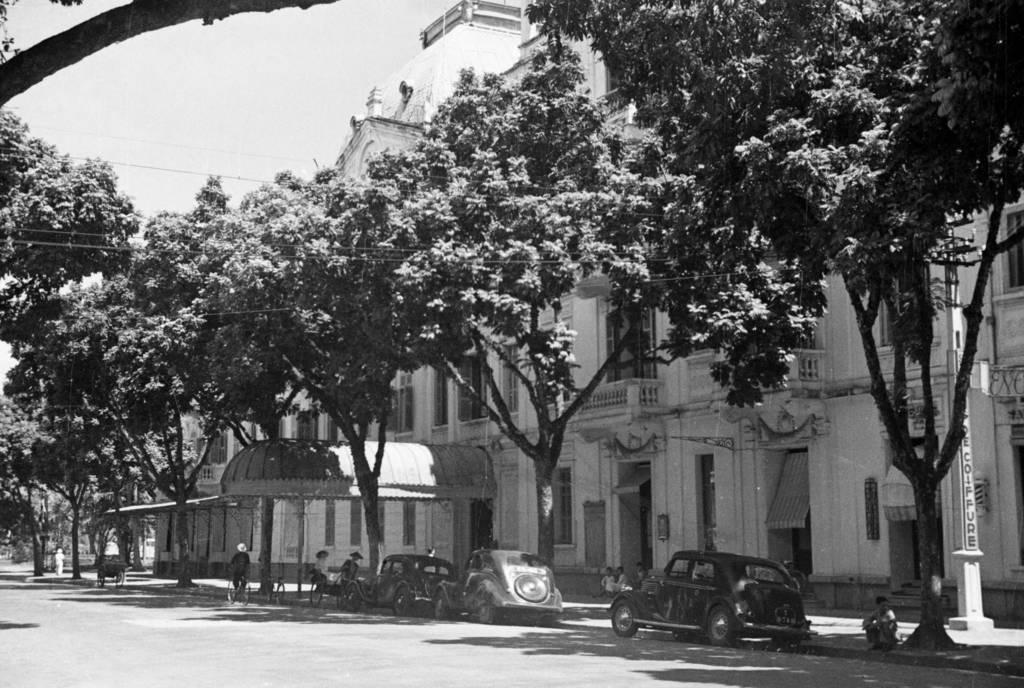What structure is located on the right side of the image? There is a building on the right side of the image. What type of vegetation is present along the road in the image? There are trees on the side of the road in the image. How many cars can be seen on the road in the image? There are three cars on the road in the image. What mode of transportation is being used by the person in the image? The person is riding a bicycle on the road in the image. What is the name of the nation that can be seen on the moon in the image? There is no mention of a nation or the moon in the image; it features a building, trees, cars, and a person riding a bicycle. 